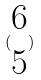<formula> <loc_0><loc_0><loc_500><loc_500>( \begin{matrix} 6 \\ 5 \end{matrix} )</formula> 